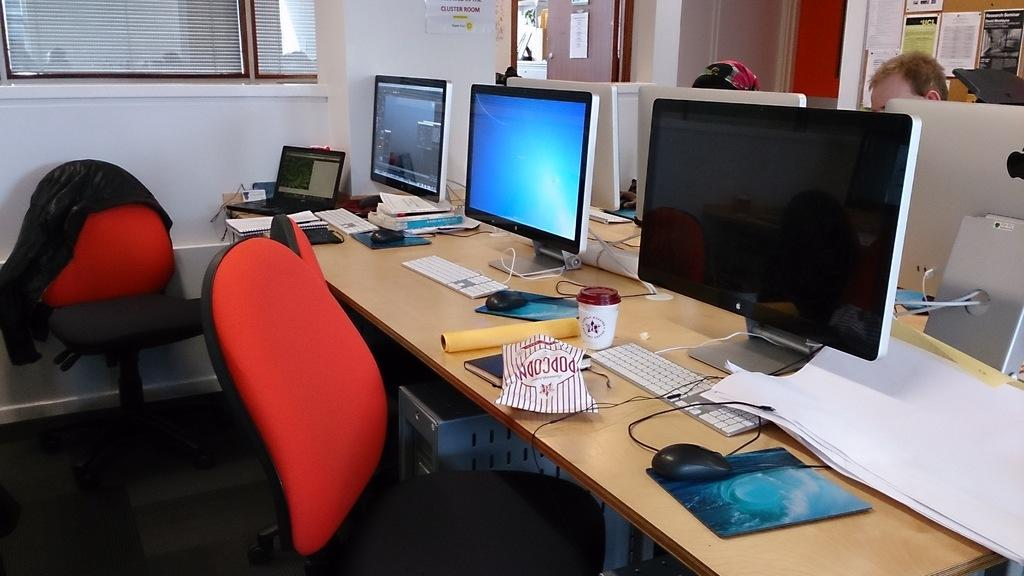Provide a one-sentence caption for the provided image. Three computers sit atop a table, and a bag labelled popcorn is in front of one of them. 